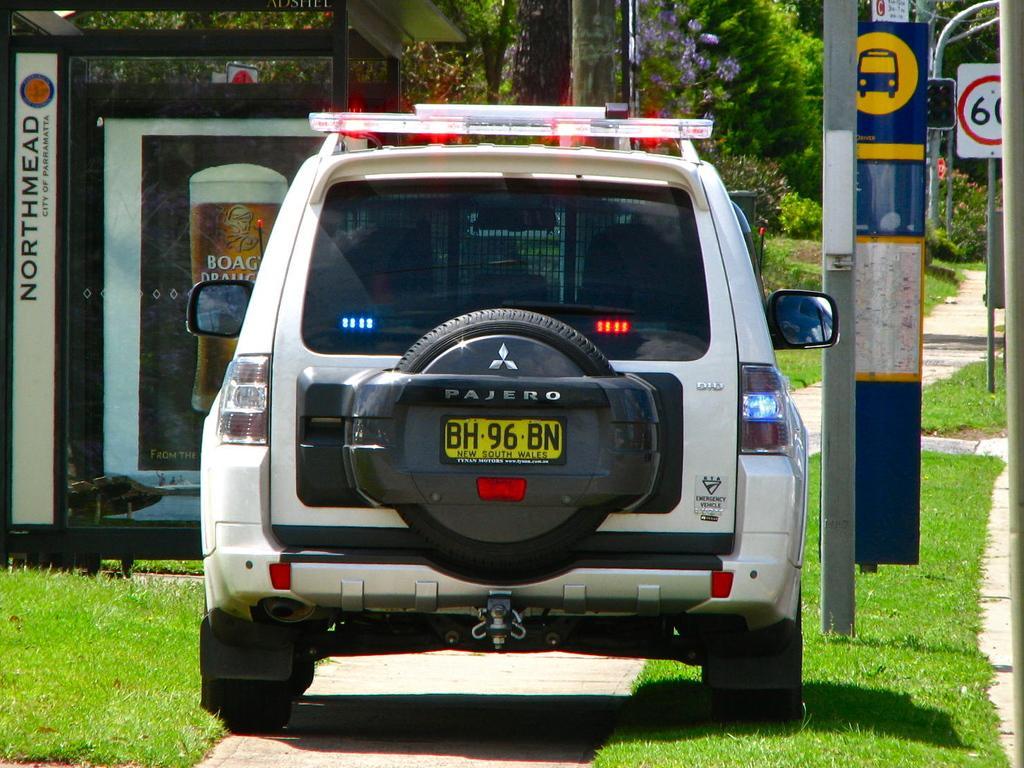Describe this image in one or two sentences. In this image we can see a vehicle with a set of lights parked on the ground. In the background, we can see a banner with some text, a group of trees and a sign board. 